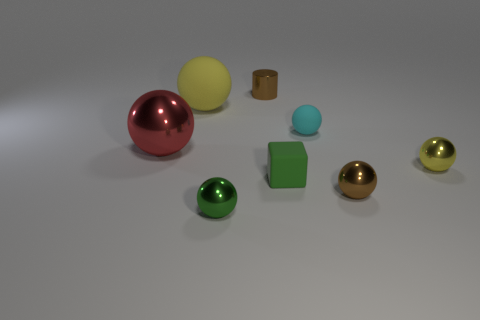Are there any other things that are the same material as the big yellow thing?
Your answer should be compact. Yes. Do the yellow thing that is to the left of the tiny green matte block and the brown ball have the same material?
Your answer should be compact. No. Is the number of cyan rubber things that are to the left of the yellow matte ball the same as the number of big yellow objects that are to the right of the shiny cylinder?
Offer a terse response. Yes. What material is the tiny ball that is the same color as the cube?
Give a very brief answer. Metal. There is a large red metallic ball behind the tiny brown ball; how many red objects are in front of it?
Give a very brief answer. 0. Is the color of the large shiny ball that is left of the small green block the same as the shiny thing that is to the right of the tiny brown sphere?
Provide a short and direct response. No. What material is the cylinder that is the same size as the block?
Keep it short and to the point. Metal. What shape is the small brown shiny object that is behind the brown metal object that is to the right of the brown metallic thing that is behind the cyan matte object?
Your response must be concise. Cylinder. There is a green matte thing that is the same size as the brown cylinder; what shape is it?
Give a very brief answer. Cube. There is a tiny thing that is on the right side of the brown thing in front of the block; how many spheres are on the left side of it?
Your response must be concise. 5. 